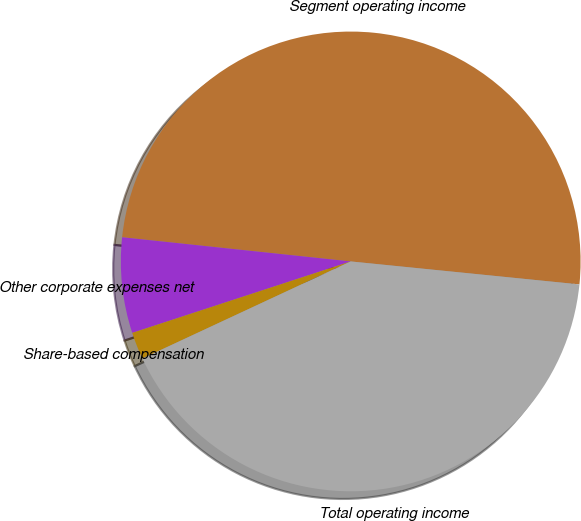Convert chart. <chart><loc_0><loc_0><loc_500><loc_500><pie_chart><fcel>Segment operating income<fcel>Other corporate expenses net<fcel>Share-based compensation<fcel>Total operating income<nl><fcel>49.92%<fcel>6.71%<fcel>1.91%<fcel>41.47%<nl></chart> 